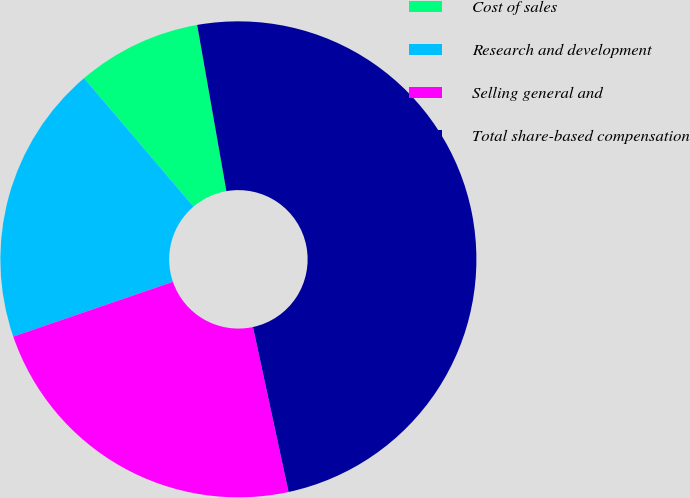<chart> <loc_0><loc_0><loc_500><loc_500><pie_chart><fcel>Cost of sales<fcel>Research and development<fcel>Selling general and<fcel>Total share-based compensation<nl><fcel>8.46%<fcel>19.03%<fcel>23.12%<fcel>49.39%<nl></chart> 